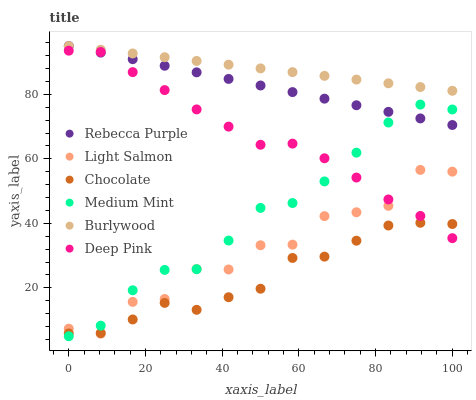Does Chocolate have the minimum area under the curve?
Answer yes or no. Yes. Does Burlywood have the maximum area under the curve?
Answer yes or no. Yes. Does Light Salmon have the minimum area under the curve?
Answer yes or no. No. Does Light Salmon have the maximum area under the curve?
Answer yes or no. No. Is Burlywood the smoothest?
Answer yes or no. Yes. Is Light Salmon the roughest?
Answer yes or no. Yes. Is Deep Pink the smoothest?
Answer yes or no. No. Is Deep Pink the roughest?
Answer yes or no. No. Does Medium Mint have the lowest value?
Answer yes or no. Yes. Does Light Salmon have the lowest value?
Answer yes or no. No. Does Rebecca Purple have the highest value?
Answer yes or no. Yes. Does Light Salmon have the highest value?
Answer yes or no. No. Is Chocolate less than Burlywood?
Answer yes or no. Yes. Is Burlywood greater than Deep Pink?
Answer yes or no. Yes. Does Medium Mint intersect Rebecca Purple?
Answer yes or no. Yes. Is Medium Mint less than Rebecca Purple?
Answer yes or no. No. Is Medium Mint greater than Rebecca Purple?
Answer yes or no. No. Does Chocolate intersect Burlywood?
Answer yes or no. No. 